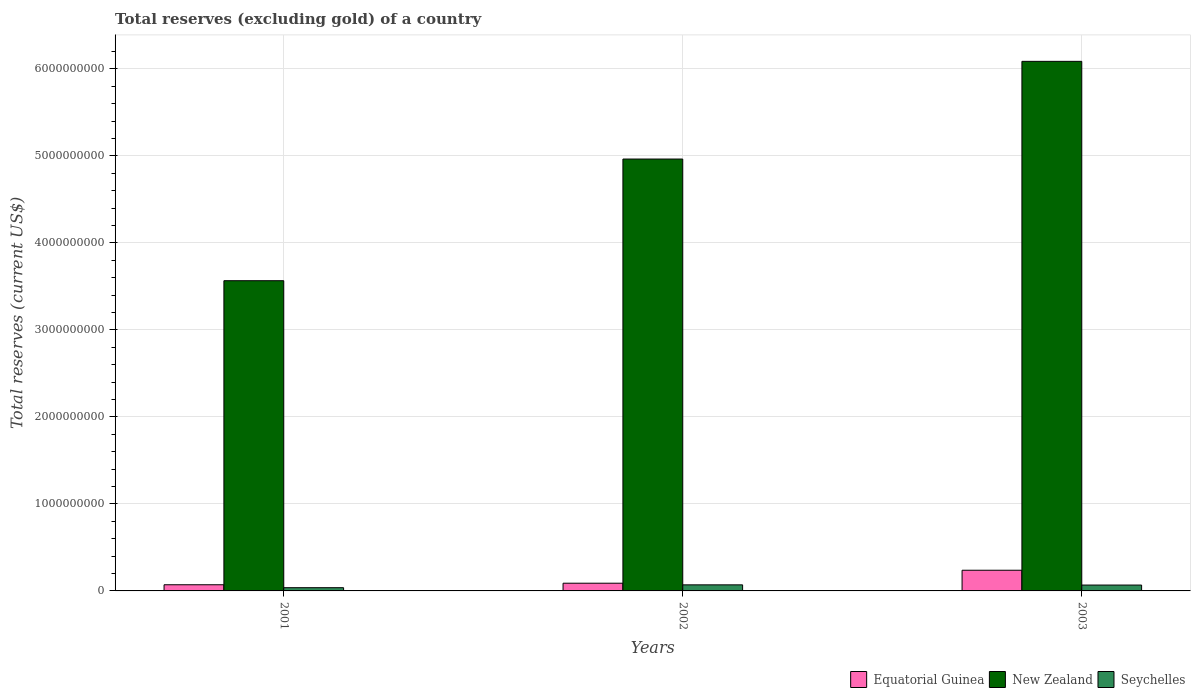How many groups of bars are there?
Ensure brevity in your answer.  3. How many bars are there on the 2nd tick from the right?
Offer a terse response. 3. What is the label of the 3rd group of bars from the left?
Provide a short and direct response. 2003. What is the total reserves (excluding gold) in Seychelles in 2002?
Ensure brevity in your answer.  6.98e+07. Across all years, what is the maximum total reserves (excluding gold) in Equatorial Guinea?
Your answer should be very brief. 2.38e+08. Across all years, what is the minimum total reserves (excluding gold) in Equatorial Guinea?
Offer a terse response. 7.09e+07. In which year was the total reserves (excluding gold) in New Zealand minimum?
Your answer should be compact. 2001. What is the total total reserves (excluding gold) in Equatorial Guinea in the graph?
Give a very brief answer. 3.97e+08. What is the difference between the total reserves (excluding gold) in New Zealand in 2002 and that in 2003?
Offer a terse response. -1.12e+09. What is the difference between the total reserves (excluding gold) in Seychelles in 2003 and the total reserves (excluding gold) in Equatorial Guinea in 2002?
Ensure brevity in your answer.  -2.12e+07. What is the average total reserves (excluding gold) in New Zealand per year?
Your response must be concise. 4.87e+09. In the year 2002, what is the difference between the total reserves (excluding gold) in Equatorial Guinea and total reserves (excluding gold) in New Zealand?
Ensure brevity in your answer.  -4.87e+09. What is the ratio of the total reserves (excluding gold) in Seychelles in 2002 to that in 2003?
Provide a succinct answer. 1.04. Is the total reserves (excluding gold) in New Zealand in 2001 less than that in 2003?
Keep it short and to the point. Yes. Is the difference between the total reserves (excluding gold) in Equatorial Guinea in 2001 and 2003 greater than the difference between the total reserves (excluding gold) in New Zealand in 2001 and 2003?
Provide a short and direct response. Yes. What is the difference between the highest and the second highest total reserves (excluding gold) in Equatorial Guinea?
Your response must be concise. 1.49e+08. What is the difference between the highest and the lowest total reserves (excluding gold) in Seychelles?
Ensure brevity in your answer.  3.27e+07. Is the sum of the total reserves (excluding gold) in Equatorial Guinea in 2001 and 2002 greater than the maximum total reserves (excluding gold) in New Zealand across all years?
Ensure brevity in your answer.  No. What does the 2nd bar from the left in 2003 represents?
Make the answer very short. New Zealand. What does the 1st bar from the right in 2002 represents?
Make the answer very short. Seychelles. Is it the case that in every year, the sum of the total reserves (excluding gold) in Seychelles and total reserves (excluding gold) in New Zealand is greater than the total reserves (excluding gold) in Equatorial Guinea?
Provide a succinct answer. Yes. How many bars are there?
Offer a very short reply. 9. Are all the bars in the graph horizontal?
Make the answer very short. No. What is the difference between two consecutive major ticks on the Y-axis?
Give a very brief answer. 1.00e+09. Does the graph contain any zero values?
Your response must be concise. No. Does the graph contain grids?
Provide a succinct answer. Yes. What is the title of the graph?
Your answer should be very brief. Total reserves (excluding gold) of a country. Does "East Asia (developing only)" appear as one of the legend labels in the graph?
Offer a very short reply. No. What is the label or title of the Y-axis?
Provide a short and direct response. Total reserves (current US$). What is the Total reserves (current US$) of Equatorial Guinea in 2001?
Make the answer very short. 7.09e+07. What is the Total reserves (current US$) in New Zealand in 2001?
Your response must be concise. 3.56e+09. What is the Total reserves (current US$) of Seychelles in 2001?
Provide a short and direct response. 3.71e+07. What is the Total reserves (current US$) of Equatorial Guinea in 2002?
Make the answer very short. 8.85e+07. What is the Total reserves (current US$) of New Zealand in 2002?
Make the answer very short. 4.96e+09. What is the Total reserves (current US$) in Seychelles in 2002?
Offer a terse response. 6.98e+07. What is the Total reserves (current US$) of Equatorial Guinea in 2003?
Provide a succinct answer. 2.38e+08. What is the Total reserves (current US$) of New Zealand in 2003?
Make the answer very short. 6.09e+09. What is the Total reserves (current US$) of Seychelles in 2003?
Provide a short and direct response. 6.74e+07. Across all years, what is the maximum Total reserves (current US$) in Equatorial Guinea?
Keep it short and to the point. 2.38e+08. Across all years, what is the maximum Total reserves (current US$) in New Zealand?
Your response must be concise. 6.09e+09. Across all years, what is the maximum Total reserves (current US$) in Seychelles?
Your answer should be very brief. 6.98e+07. Across all years, what is the minimum Total reserves (current US$) in Equatorial Guinea?
Make the answer very short. 7.09e+07. Across all years, what is the minimum Total reserves (current US$) in New Zealand?
Your answer should be compact. 3.56e+09. Across all years, what is the minimum Total reserves (current US$) of Seychelles?
Offer a very short reply. 3.71e+07. What is the total Total reserves (current US$) in Equatorial Guinea in the graph?
Your answer should be very brief. 3.97e+08. What is the total Total reserves (current US$) in New Zealand in the graph?
Your answer should be compact. 1.46e+1. What is the total Total reserves (current US$) in Seychelles in the graph?
Offer a very short reply. 1.74e+08. What is the difference between the Total reserves (current US$) in Equatorial Guinea in 2001 and that in 2002?
Ensure brevity in your answer.  -1.77e+07. What is the difference between the Total reserves (current US$) of New Zealand in 2001 and that in 2002?
Your answer should be very brief. -1.40e+09. What is the difference between the Total reserves (current US$) of Seychelles in 2001 and that in 2002?
Your response must be concise. -3.27e+07. What is the difference between the Total reserves (current US$) in Equatorial Guinea in 2001 and that in 2003?
Provide a succinct answer. -1.67e+08. What is the difference between the Total reserves (current US$) in New Zealand in 2001 and that in 2003?
Ensure brevity in your answer.  -2.52e+09. What is the difference between the Total reserves (current US$) in Seychelles in 2001 and that in 2003?
Offer a terse response. -3.03e+07. What is the difference between the Total reserves (current US$) in Equatorial Guinea in 2002 and that in 2003?
Ensure brevity in your answer.  -1.49e+08. What is the difference between the Total reserves (current US$) of New Zealand in 2002 and that in 2003?
Your response must be concise. -1.12e+09. What is the difference between the Total reserves (current US$) of Seychelles in 2002 and that in 2003?
Make the answer very short. 2.41e+06. What is the difference between the Total reserves (current US$) of Equatorial Guinea in 2001 and the Total reserves (current US$) of New Zealand in 2002?
Your answer should be compact. -4.89e+09. What is the difference between the Total reserves (current US$) of Equatorial Guinea in 2001 and the Total reserves (current US$) of Seychelles in 2002?
Provide a succinct answer. 1.06e+06. What is the difference between the Total reserves (current US$) in New Zealand in 2001 and the Total reserves (current US$) in Seychelles in 2002?
Give a very brief answer. 3.49e+09. What is the difference between the Total reserves (current US$) of Equatorial Guinea in 2001 and the Total reserves (current US$) of New Zealand in 2003?
Provide a short and direct response. -6.01e+09. What is the difference between the Total reserves (current US$) in Equatorial Guinea in 2001 and the Total reserves (current US$) in Seychelles in 2003?
Provide a succinct answer. 3.46e+06. What is the difference between the Total reserves (current US$) in New Zealand in 2001 and the Total reserves (current US$) in Seychelles in 2003?
Your answer should be compact. 3.50e+09. What is the difference between the Total reserves (current US$) in Equatorial Guinea in 2002 and the Total reserves (current US$) in New Zealand in 2003?
Keep it short and to the point. -6.00e+09. What is the difference between the Total reserves (current US$) in Equatorial Guinea in 2002 and the Total reserves (current US$) in Seychelles in 2003?
Your response must be concise. 2.12e+07. What is the difference between the Total reserves (current US$) of New Zealand in 2002 and the Total reserves (current US$) of Seychelles in 2003?
Offer a terse response. 4.90e+09. What is the average Total reserves (current US$) in Equatorial Guinea per year?
Keep it short and to the point. 1.32e+08. What is the average Total reserves (current US$) of New Zealand per year?
Give a very brief answer. 4.87e+09. What is the average Total reserves (current US$) in Seychelles per year?
Give a very brief answer. 5.81e+07. In the year 2001, what is the difference between the Total reserves (current US$) of Equatorial Guinea and Total reserves (current US$) of New Zealand?
Give a very brief answer. -3.49e+09. In the year 2001, what is the difference between the Total reserves (current US$) of Equatorial Guinea and Total reserves (current US$) of Seychelles?
Your answer should be compact. 3.37e+07. In the year 2001, what is the difference between the Total reserves (current US$) of New Zealand and Total reserves (current US$) of Seychelles?
Offer a very short reply. 3.53e+09. In the year 2002, what is the difference between the Total reserves (current US$) of Equatorial Guinea and Total reserves (current US$) of New Zealand?
Give a very brief answer. -4.87e+09. In the year 2002, what is the difference between the Total reserves (current US$) of Equatorial Guinea and Total reserves (current US$) of Seychelles?
Your answer should be compact. 1.87e+07. In the year 2002, what is the difference between the Total reserves (current US$) of New Zealand and Total reserves (current US$) of Seychelles?
Your answer should be compact. 4.89e+09. In the year 2003, what is the difference between the Total reserves (current US$) in Equatorial Guinea and Total reserves (current US$) in New Zealand?
Offer a very short reply. -5.85e+09. In the year 2003, what is the difference between the Total reserves (current US$) in Equatorial Guinea and Total reserves (current US$) in Seychelles?
Offer a terse response. 1.70e+08. In the year 2003, what is the difference between the Total reserves (current US$) of New Zealand and Total reserves (current US$) of Seychelles?
Offer a very short reply. 6.02e+09. What is the ratio of the Total reserves (current US$) of Equatorial Guinea in 2001 to that in 2002?
Make the answer very short. 0.8. What is the ratio of the Total reserves (current US$) in New Zealand in 2001 to that in 2002?
Provide a short and direct response. 0.72. What is the ratio of the Total reserves (current US$) of Seychelles in 2001 to that in 2002?
Offer a terse response. 0.53. What is the ratio of the Total reserves (current US$) of Equatorial Guinea in 2001 to that in 2003?
Ensure brevity in your answer.  0.3. What is the ratio of the Total reserves (current US$) in New Zealand in 2001 to that in 2003?
Keep it short and to the point. 0.59. What is the ratio of the Total reserves (current US$) in Seychelles in 2001 to that in 2003?
Your answer should be very brief. 0.55. What is the ratio of the Total reserves (current US$) of Equatorial Guinea in 2002 to that in 2003?
Give a very brief answer. 0.37. What is the ratio of the Total reserves (current US$) of New Zealand in 2002 to that in 2003?
Offer a terse response. 0.82. What is the ratio of the Total reserves (current US$) of Seychelles in 2002 to that in 2003?
Provide a short and direct response. 1.04. What is the difference between the highest and the second highest Total reserves (current US$) of Equatorial Guinea?
Provide a succinct answer. 1.49e+08. What is the difference between the highest and the second highest Total reserves (current US$) in New Zealand?
Give a very brief answer. 1.12e+09. What is the difference between the highest and the second highest Total reserves (current US$) in Seychelles?
Provide a short and direct response. 2.41e+06. What is the difference between the highest and the lowest Total reserves (current US$) in Equatorial Guinea?
Give a very brief answer. 1.67e+08. What is the difference between the highest and the lowest Total reserves (current US$) in New Zealand?
Offer a very short reply. 2.52e+09. What is the difference between the highest and the lowest Total reserves (current US$) in Seychelles?
Provide a succinct answer. 3.27e+07. 